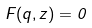<formula> <loc_0><loc_0><loc_500><loc_500>F ( q , z ) = 0</formula> 